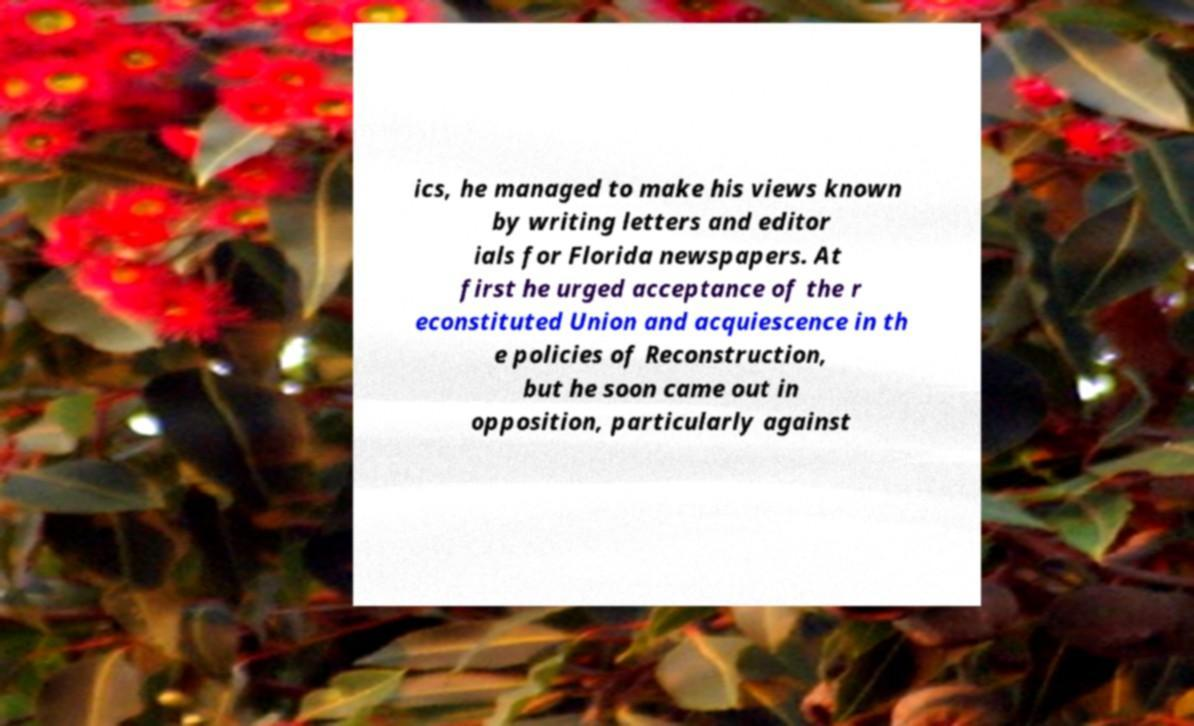I need the written content from this picture converted into text. Can you do that? ics, he managed to make his views known by writing letters and editor ials for Florida newspapers. At first he urged acceptance of the r econstituted Union and acquiescence in th e policies of Reconstruction, but he soon came out in opposition, particularly against 